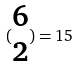<formula> <loc_0><loc_0><loc_500><loc_500>( \begin{matrix} 6 \\ 2 \end{matrix} ) = 1 5</formula> 